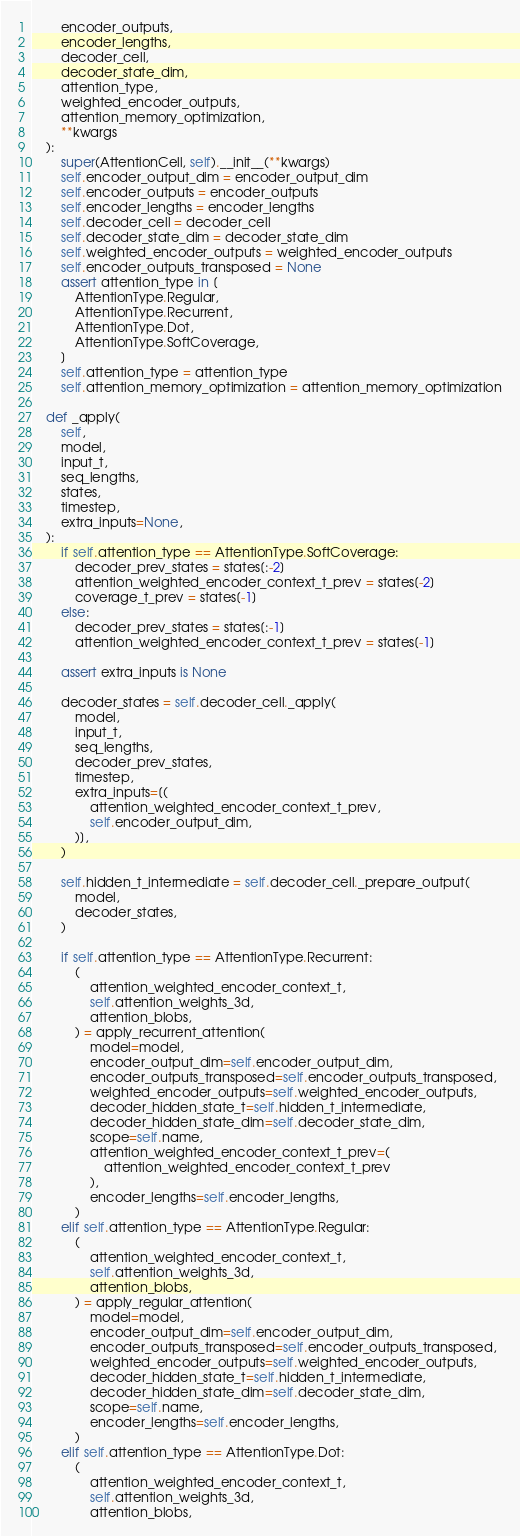<code> <loc_0><loc_0><loc_500><loc_500><_Python_>        encoder_outputs,
        encoder_lengths,
        decoder_cell,
        decoder_state_dim,
        attention_type,
        weighted_encoder_outputs,
        attention_memory_optimization,
        **kwargs
    ):
        super(AttentionCell, self).__init__(**kwargs)
        self.encoder_output_dim = encoder_output_dim
        self.encoder_outputs = encoder_outputs
        self.encoder_lengths = encoder_lengths
        self.decoder_cell = decoder_cell
        self.decoder_state_dim = decoder_state_dim
        self.weighted_encoder_outputs = weighted_encoder_outputs
        self.encoder_outputs_transposed = None
        assert attention_type in [
            AttentionType.Regular,
            AttentionType.Recurrent,
            AttentionType.Dot,
            AttentionType.SoftCoverage,
        ]
        self.attention_type = attention_type
        self.attention_memory_optimization = attention_memory_optimization

    def _apply(
        self,
        model,
        input_t,
        seq_lengths,
        states,
        timestep,
        extra_inputs=None,
    ):
        if self.attention_type == AttentionType.SoftCoverage:
            decoder_prev_states = states[:-2]
            attention_weighted_encoder_context_t_prev = states[-2]
            coverage_t_prev = states[-1]
        else:
            decoder_prev_states = states[:-1]
            attention_weighted_encoder_context_t_prev = states[-1]

        assert extra_inputs is None

        decoder_states = self.decoder_cell._apply(
            model,
            input_t,
            seq_lengths,
            decoder_prev_states,
            timestep,
            extra_inputs=[(
                attention_weighted_encoder_context_t_prev,
                self.encoder_output_dim,
            )],
        )

        self.hidden_t_intermediate = self.decoder_cell._prepare_output(
            model,
            decoder_states,
        )

        if self.attention_type == AttentionType.Recurrent:
            (
                attention_weighted_encoder_context_t,
                self.attention_weights_3d,
                attention_blobs,
            ) = apply_recurrent_attention(
                model=model,
                encoder_output_dim=self.encoder_output_dim,
                encoder_outputs_transposed=self.encoder_outputs_transposed,
                weighted_encoder_outputs=self.weighted_encoder_outputs,
                decoder_hidden_state_t=self.hidden_t_intermediate,
                decoder_hidden_state_dim=self.decoder_state_dim,
                scope=self.name,
                attention_weighted_encoder_context_t_prev=(
                    attention_weighted_encoder_context_t_prev
                ),
                encoder_lengths=self.encoder_lengths,
            )
        elif self.attention_type == AttentionType.Regular:
            (
                attention_weighted_encoder_context_t,
                self.attention_weights_3d,
                attention_blobs,
            ) = apply_regular_attention(
                model=model,
                encoder_output_dim=self.encoder_output_dim,
                encoder_outputs_transposed=self.encoder_outputs_transposed,
                weighted_encoder_outputs=self.weighted_encoder_outputs,
                decoder_hidden_state_t=self.hidden_t_intermediate,
                decoder_hidden_state_dim=self.decoder_state_dim,
                scope=self.name,
                encoder_lengths=self.encoder_lengths,
            )
        elif self.attention_type == AttentionType.Dot:
            (
                attention_weighted_encoder_context_t,
                self.attention_weights_3d,
                attention_blobs,</code> 